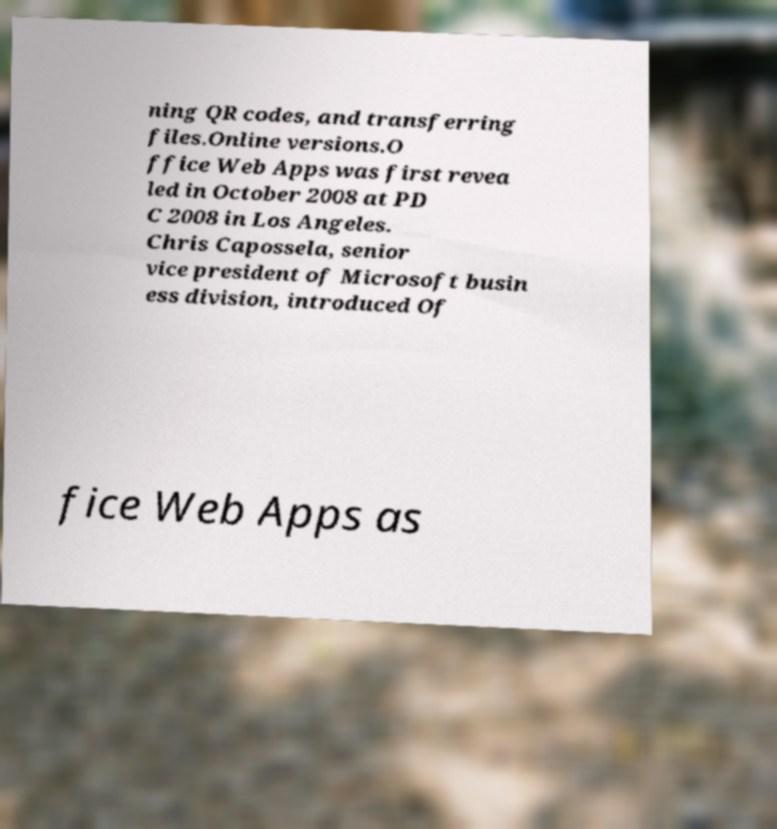There's text embedded in this image that I need extracted. Can you transcribe it verbatim? ning QR codes, and transferring files.Online versions.O ffice Web Apps was first revea led in October 2008 at PD C 2008 in Los Angeles. Chris Capossela, senior vice president of Microsoft busin ess division, introduced Of fice Web Apps as 